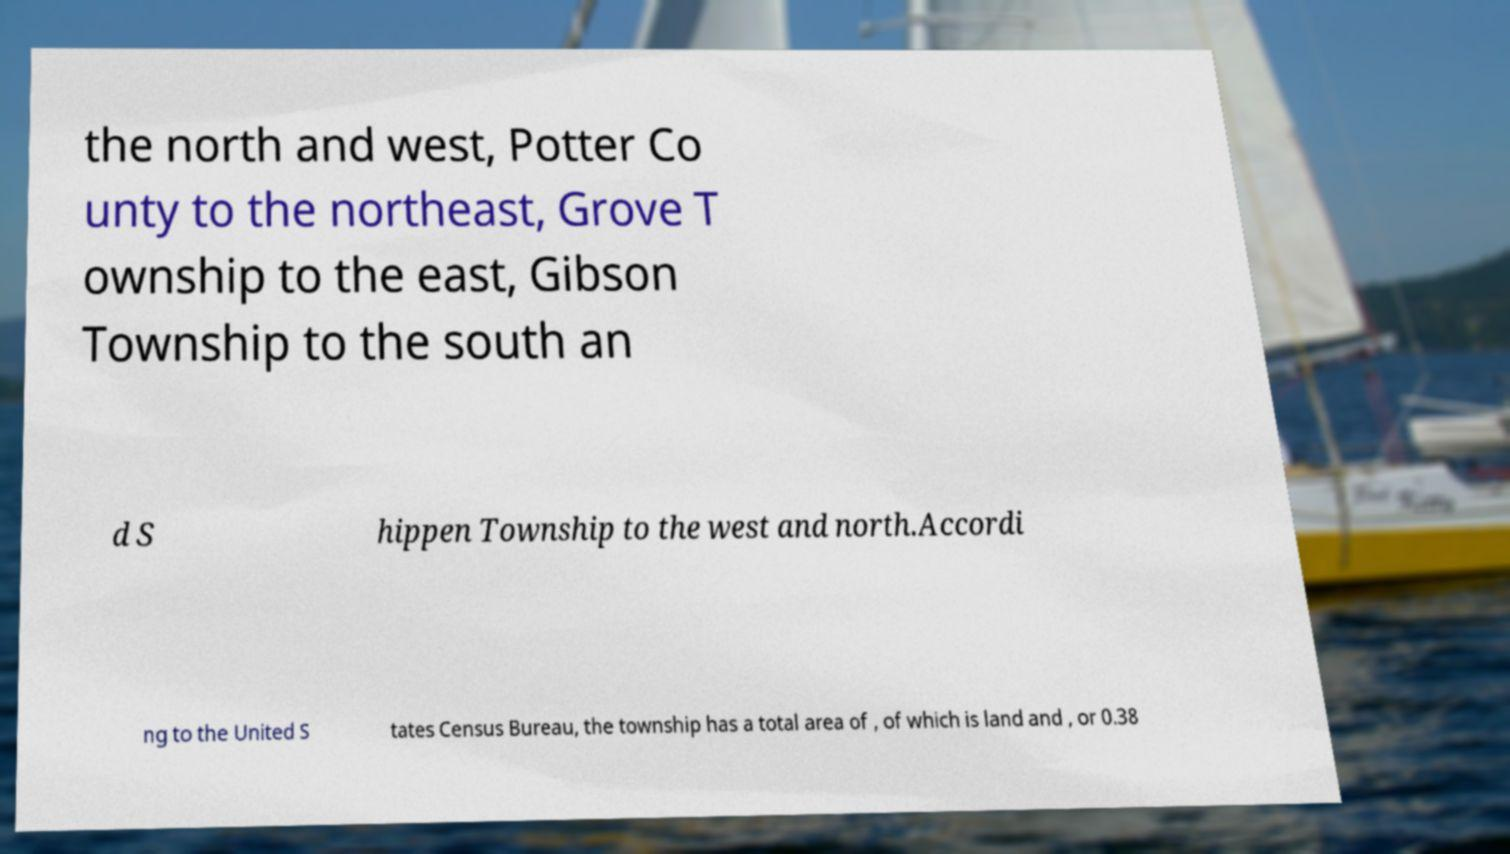There's text embedded in this image that I need extracted. Can you transcribe it verbatim? the north and west, Potter Co unty to the northeast, Grove T ownship to the east, Gibson Township to the south an d S hippen Township to the west and north.Accordi ng to the United S tates Census Bureau, the township has a total area of , of which is land and , or 0.38 